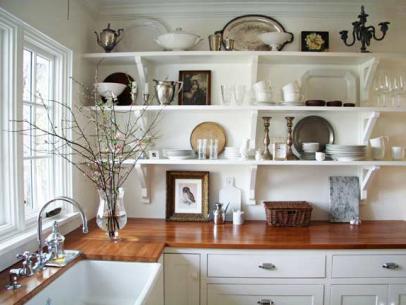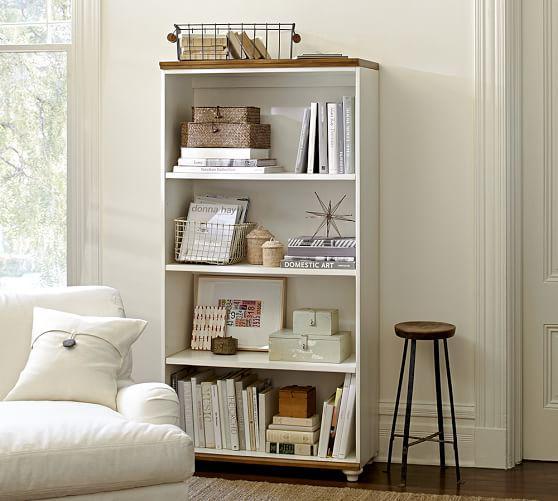The first image is the image on the left, the second image is the image on the right. For the images shown, is this caption "A room image features seating furniture on the right and a bookcase with at least 8 shelves." true? Answer yes or no. No. The first image is the image on the left, the second image is the image on the right. Evaluate the accuracy of this statement regarding the images: "In one image, a free-standing white shelf is in front of a wall.". Is it true? Answer yes or no. Yes. 